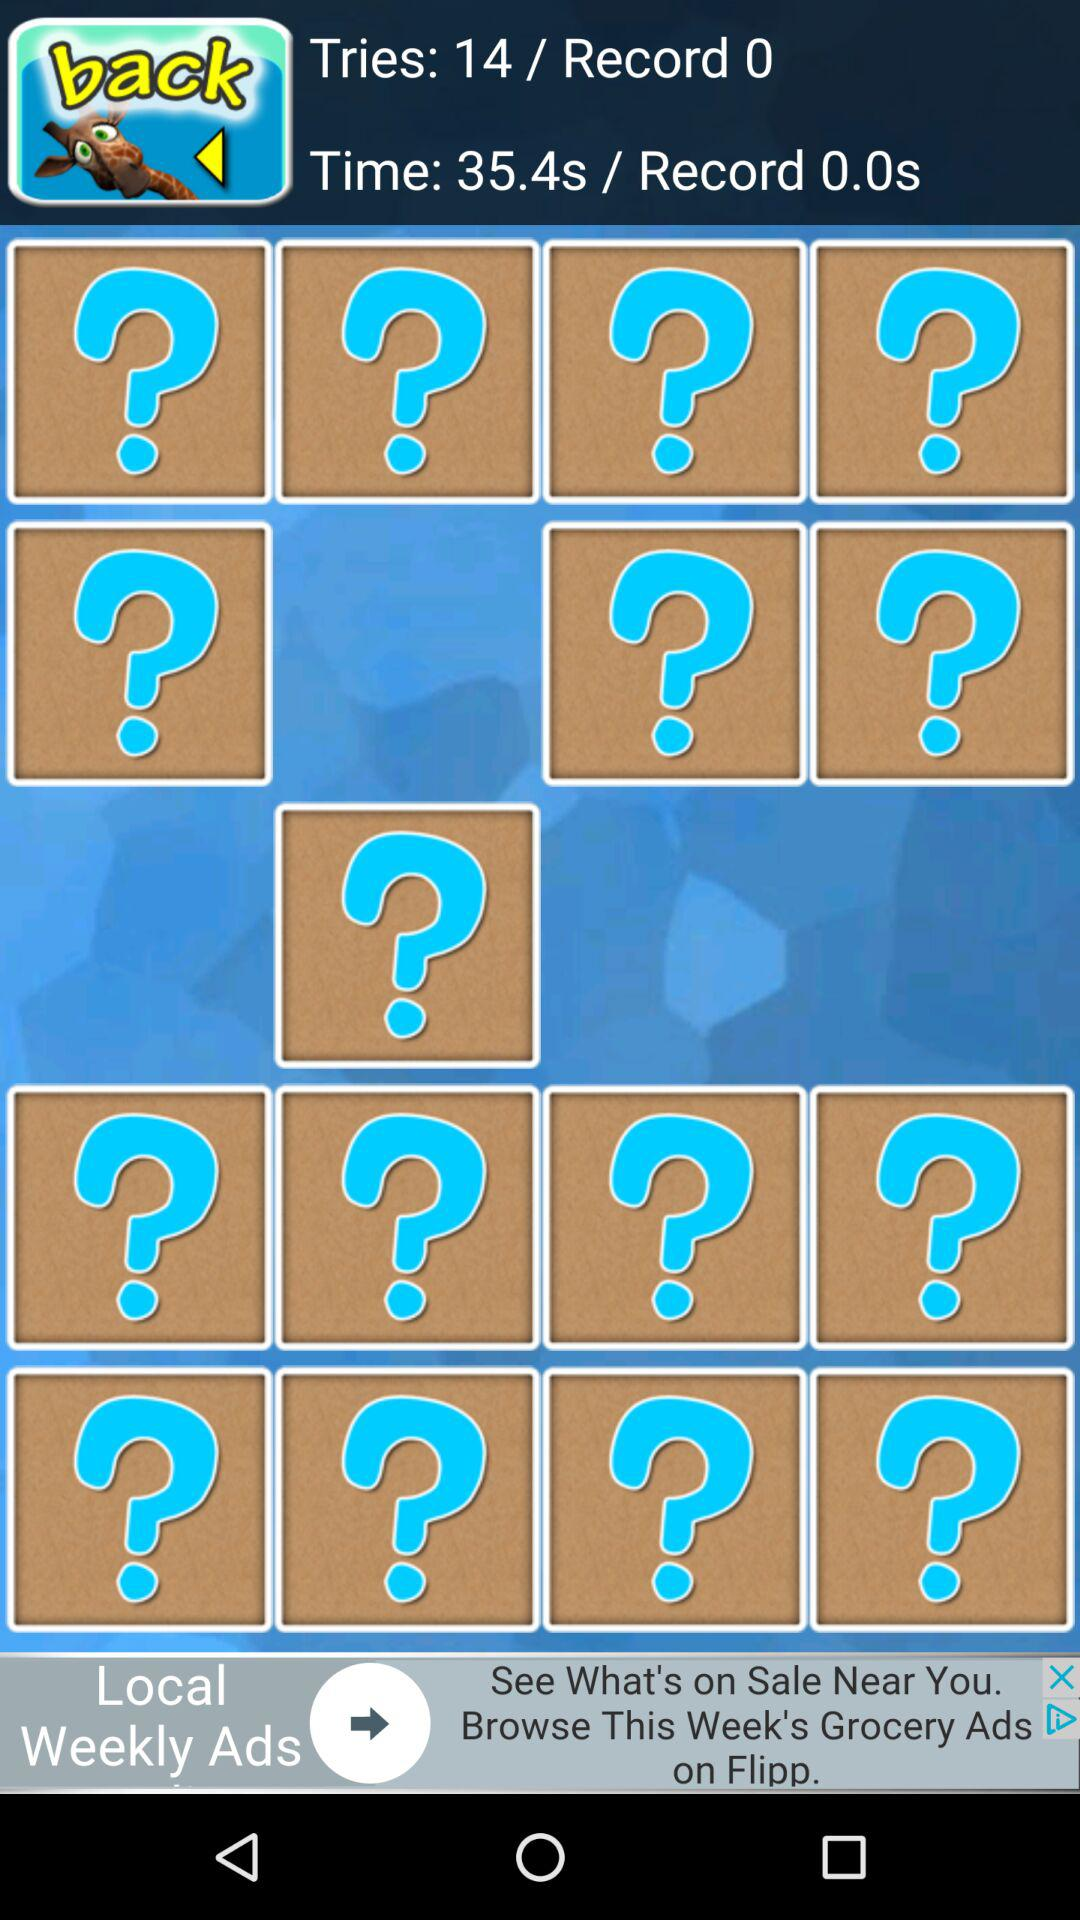What is the mentioned time? The mentioned time is 35.4 seconds. 